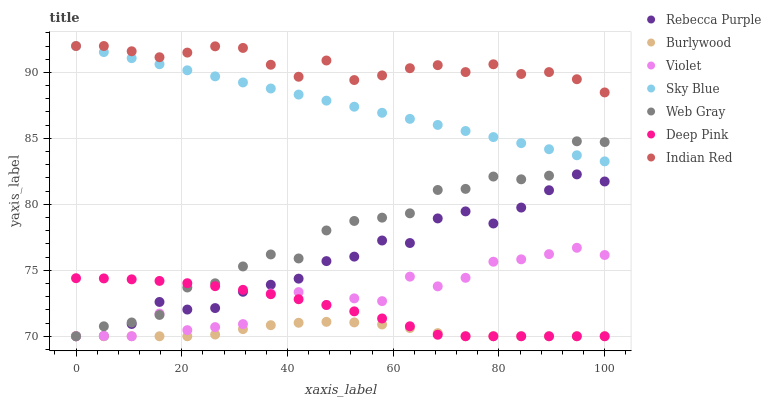Does Burlywood have the minimum area under the curve?
Answer yes or no. Yes. Does Indian Red have the maximum area under the curve?
Answer yes or no. Yes. Does Deep Pink have the minimum area under the curve?
Answer yes or no. No. Does Deep Pink have the maximum area under the curve?
Answer yes or no. No. Is Sky Blue the smoothest?
Answer yes or no. Yes. Is Violet the roughest?
Answer yes or no. Yes. Is Burlywood the smoothest?
Answer yes or no. No. Is Burlywood the roughest?
Answer yes or no. No. Does Web Gray have the lowest value?
Answer yes or no. Yes. Does Indian Red have the lowest value?
Answer yes or no. No. Does Sky Blue have the highest value?
Answer yes or no. Yes. Does Deep Pink have the highest value?
Answer yes or no. No. Is Burlywood less than Sky Blue?
Answer yes or no. Yes. Is Indian Red greater than Rebecca Purple?
Answer yes or no. Yes. Does Violet intersect Rebecca Purple?
Answer yes or no. Yes. Is Violet less than Rebecca Purple?
Answer yes or no. No. Is Violet greater than Rebecca Purple?
Answer yes or no. No. Does Burlywood intersect Sky Blue?
Answer yes or no. No. 